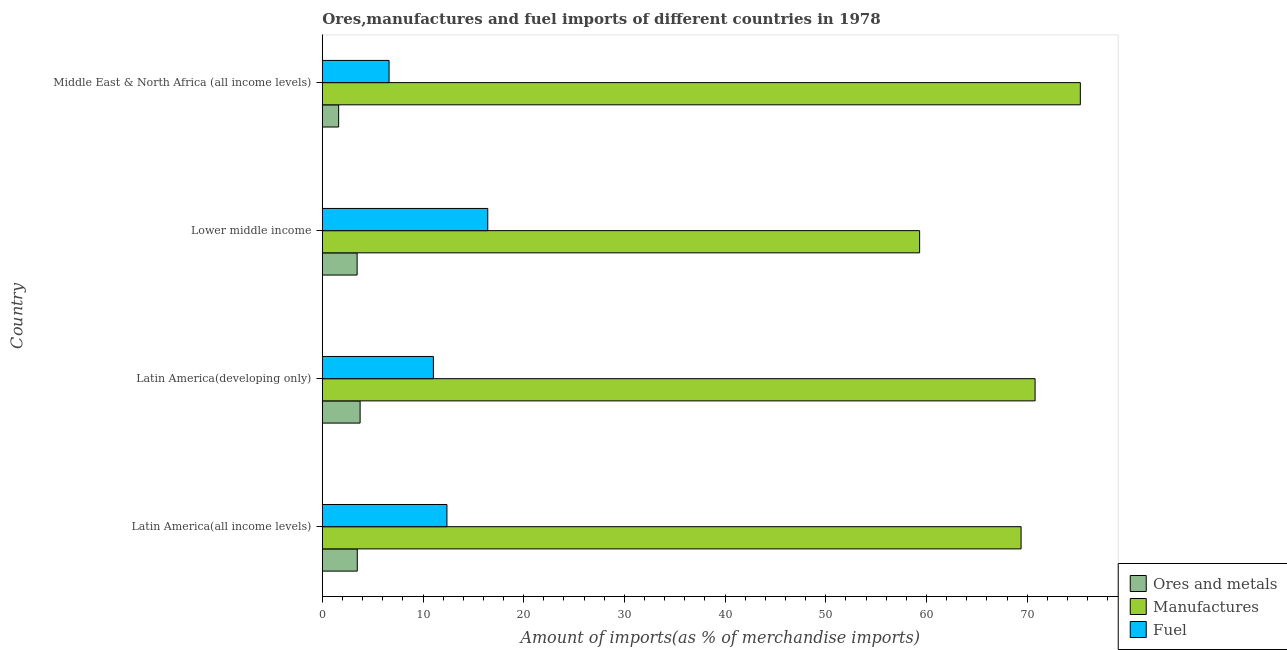How many different coloured bars are there?
Your response must be concise. 3. How many bars are there on the 3rd tick from the top?
Keep it short and to the point. 3. How many bars are there on the 4th tick from the bottom?
Your answer should be very brief. 3. What is the label of the 1st group of bars from the top?
Offer a very short reply. Middle East & North Africa (all income levels). What is the percentage of fuel imports in Lower middle income?
Your answer should be compact. 16.43. Across all countries, what is the maximum percentage of fuel imports?
Your response must be concise. 16.43. Across all countries, what is the minimum percentage of ores and metals imports?
Ensure brevity in your answer.  1.62. In which country was the percentage of manufactures imports maximum?
Provide a short and direct response. Middle East & North Africa (all income levels). In which country was the percentage of ores and metals imports minimum?
Your answer should be compact. Middle East & North Africa (all income levels). What is the total percentage of fuel imports in the graph?
Offer a very short reply. 46.46. What is the difference between the percentage of fuel imports in Latin America(all income levels) and that in Latin America(developing only)?
Your response must be concise. 1.35. What is the difference between the percentage of ores and metals imports in Latin America(developing only) and the percentage of fuel imports in Latin America(all income levels)?
Keep it short and to the point. -8.62. What is the average percentage of ores and metals imports per country?
Keep it short and to the point. 3.08. What is the difference between the percentage of manufactures imports and percentage of ores and metals imports in Middle East & North Africa (all income levels)?
Keep it short and to the point. 73.66. What is the ratio of the percentage of ores and metals imports in Lower middle income to that in Middle East & North Africa (all income levels)?
Offer a very short reply. 2.13. Is the percentage of fuel imports in Latin America(developing only) less than that in Lower middle income?
Provide a short and direct response. Yes. What is the difference between the highest and the second highest percentage of fuel imports?
Your response must be concise. 4.05. Is the sum of the percentage of ores and metals imports in Latin America(developing only) and Middle East & North Africa (all income levels) greater than the maximum percentage of manufactures imports across all countries?
Your response must be concise. No. What does the 3rd bar from the top in Latin America(all income levels) represents?
Keep it short and to the point. Ores and metals. What does the 1st bar from the bottom in Lower middle income represents?
Give a very brief answer. Ores and metals. How many bars are there?
Your answer should be very brief. 12. Are all the bars in the graph horizontal?
Provide a short and direct response. Yes. How many countries are there in the graph?
Keep it short and to the point. 4. Does the graph contain any zero values?
Provide a succinct answer. No. Where does the legend appear in the graph?
Your answer should be compact. Bottom right. How many legend labels are there?
Your answer should be compact. 3. How are the legend labels stacked?
Your response must be concise. Vertical. What is the title of the graph?
Offer a very short reply. Ores,manufactures and fuel imports of different countries in 1978. Does "Unpaid family workers" appear as one of the legend labels in the graph?
Provide a short and direct response. No. What is the label or title of the X-axis?
Make the answer very short. Amount of imports(as % of merchandise imports). What is the Amount of imports(as % of merchandise imports) of Ores and metals in Latin America(all income levels)?
Give a very brief answer. 3.47. What is the Amount of imports(as % of merchandise imports) in Manufactures in Latin America(all income levels)?
Offer a terse response. 69.39. What is the Amount of imports(as % of merchandise imports) in Fuel in Latin America(all income levels)?
Your response must be concise. 12.38. What is the Amount of imports(as % of merchandise imports) in Ores and metals in Latin America(developing only)?
Provide a short and direct response. 3.75. What is the Amount of imports(as % of merchandise imports) of Manufactures in Latin America(developing only)?
Your response must be concise. 70.79. What is the Amount of imports(as % of merchandise imports) in Fuel in Latin America(developing only)?
Give a very brief answer. 11.03. What is the Amount of imports(as % of merchandise imports) in Ores and metals in Lower middle income?
Your answer should be compact. 3.46. What is the Amount of imports(as % of merchandise imports) of Manufactures in Lower middle income?
Keep it short and to the point. 59.32. What is the Amount of imports(as % of merchandise imports) of Fuel in Lower middle income?
Your answer should be compact. 16.43. What is the Amount of imports(as % of merchandise imports) of Ores and metals in Middle East & North Africa (all income levels)?
Give a very brief answer. 1.62. What is the Amount of imports(as % of merchandise imports) in Manufactures in Middle East & North Africa (all income levels)?
Offer a very short reply. 75.28. What is the Amount of imports(as % of merchandise imports) of Fuel in Middle East & North Africa (all income levels)?
Keep it short and to the point. 6.63. Across all countries, what is the maximum Amount of imports(as % of merchandise imports) in Ores and metals?
Provide a short and direct response. 3.75. Across all countries, what is the maximum Amount of imports(as % of merchandise imports) in Manufactures?
Your response must be concise. 75.28. Across all countries, what is the maximum Amount of imports(as % of merchandise imports) in Fuel?
Ensure brevity in your answer.  16.43. Across all countries, what is the minimum Amount of imports(as % of merchandise imports) of Ores and metals?
Make the answer very short. 1.62. Across all countries, what is the minimum Amount of imports(as % of merchandise imports) in Manufactures?
Offer a very short reply. 59.32. Across all countries, what is the minimum Amount of imports(as % of merchandise imports) in Fuel?
Keep it short and to the point. 6.63. What is the total Amount of imports(as % of merchandise imports) in Ores and metals in the graph?
Give a very brief answer. 12.3. What is the total Amount of imports(as % of merchandise imports) in Manufactures in the graph?
Offer a very short reply. 274.78. What is the total Amount of imports(as % of merchandise imports) in Fuel in the graph?
Your answer should be compact. 46.46. What is the difference between the Amount of imports(as % of merchandise imports) of Ores and metals in Latin America(all income levels) and that in Latin America(developing only)?
Provide a succinct answer. -0.28. What is the difference between the Amount of imports(as % of merchandise imports) of Manufactures in Latin America(all income levels) and that in Latin America(developing only)?
Make the answer very short. -1.39. What is the difference between the Amount of imports(as % of merchandise imports) in Fuel in Latin America(all income levels) and that in Latin America(developing only)?
Give a very brief answer. 1.35. What is the difference between the Amount of imports(as % of merchandise imports) in Ores and metals in Latin America(all income levels) and that in Lower middle income?
Provide a short and direct response. 0.02. What is the difference between the Amount of imports(as % of merchandise imports) of Manufactures in Latin America(all income levels) and that in Lower middle income?
Offer a terse response. 10.08. What is the difference between the Amount of imports(as % of merchandise imports) in Fuel in Latin America(all income levels) and that in Lower middle income?
Provide a succinct answer. -4.05. What is the difference between the Amount of imports(as % of merchandise imports) in Ores and metals in Latin America(all income levels) and that in Middle East & North Africa (all income levels)?
Offer a terse response. 1.85. What is the difference between the Amount of imports(as % of merchandise imports) of Manufactures in Latin America(all income levels) and that in Middle East & North Africa (all income levels)?
Ensure brevity in your answer.  -5.88. What is the difference between the Amount of imports(as % of merchandise imports) of Fuel in Latin America(all income levels) and that in Middle East & North Africa (all income levels)?
Your answer should be very brief. 5.75. What is the difference between the Amount of imports(as % of merchandise imports) in Ores and metals in Latin America(developing only) and that in Lower middle income?
Your answer should be very brief. 0.3. What is the difference between the Amount of imports(as % of merchandise imports) of Manufactures in Latin America(developing only) and that in Lower middle income?
Provide a short and direct response. 11.47. What is the difference between the Amount of imports(as % of merchandise imports) of Fuel in Latin America(developing only) and that in Lower middle income?
Make the answer very short. -5.4. What is the difference between the Amount of imports(as % of merchandise imports) in Ores and metals in Latin America(developing only) and that in Middle East & North Africa (all income levels)?
Make the answer very short. 2.13. What is the difference between the Amount of imports(as % of merchandise imports) of Manufactures in Latin America(developing only) and that in Middle East & North Africa (all income levels)?
Offer a terse response. -4.49. What is the difference between the Amount of imports(as % of merchandise imports) of Fuel in Latin America(developing only) and that in Middle East & North Africa (all income levels)?
Provide a short and direct response. 4.4. What is the difference between the Amount of imports(as % of merchandise imports) in Ores and metals in Lower middle income and that in Middle East & North Africa (all income levels)?
Provide a succinct answer. 1.84. What is the difference between the Amount of imports(as % of merchandise imports) in Manufactures in Lower middle income and that in Middle East & North Africa (all income levels)?
Offer a terse response. -15.96. What is the difference between the Amount of imports(as % of merchandise imports) in Fuel in Lower middle income and that in Middle East & North Africa (all income levels)?
Offer a terse response. 9.8. What is the difference between the Amount of imports(as % of merchandise imports) of Ores and metals in Latin America(all income levels) and the Amount of imports(as % of merchandise imports) of Manufactures in Latin America(developing only)?
Offer a terse response. -67.32. What is the difference between the Amount of imports(as % of merchandise imports) in Ores and metals in Latin America(all income levels) and the Amount of imports(as % of merchandise imports) in Fuel in Latin America(developing only)?
Your response must be concise. -7.56. What is the difference between the Amount of imports(as % of merchandise imports) in Manufactures in Latin America(all income levels) and the Amount of imports(as % of merchandise imports) in Fuel in Latin America(developing only)?
Give a very brief answer. 58.37. What is the difference between the Amount of imports(as % of merchandise imports) of Ores and metals in Latin America(all income levels) and the Amount of imports(as % of merchandise imports) of Manufactures in Lower middle income?
Your answer should be very brief. -55.85. What is the difference between the Amount of imports(as % of merchandise imports) in Ores and metals in Latin America(all income levels) and the Amount of imports(as % of merchandise imports) in Fuel in Lower middle income?
Ensure brevity in your answer.  -12.96. What is the difference between the Amount of imports(as % of merchandise imports) of Manufactures in Latin America(all income levels) and the Amount of imports(as % of merchandise imports) of Fuel in Lower middle income?
Your answer should be very brief. 52.97. What is the difference between the Amount of imports(as % of merchandise imports) of Ores and metals in Latin America(all income levels) and the Amount of imports(as % of merchandise imports) of Manufactures in Middle East & North Africa (all income levels)?
Provide a short and direct response. -71.81. What is the difference between the Amount of imports(as % of merchandise imports) in Ores and metals in Latin America(all income levels) and the Amount of imports(as % of merchandise imports) in Fuel in Middle East & North Africa (all income levels)?
Offer a terse response. -3.16. What is the difference between the Amount of imports(as % of merchandise imports) in Manufactures in Latin America(all income levels) and the Amount of imports(as % of merchandise imports) in Fuel in Middle East & North Africa (all income levels)?
Your answer should be compact. 62.77. What is the difference between the Amount of imports(as % of merchandise imports) of Ores and metals in Latin America(developing only) and the Amount of imports(as % of merchandise imports) of Manufactures in Lower middle income?
Keep it short and to the point. -55.57. What is the difference between the Amount of imports(as % of merchandise imports) of Ores and metals in Latin America(developing only) and the Amount of imports(as % of merchandise imports) of Fuel in Lower middle income?
Make the answer very short. -12.68. What is the difference between the Amount of imports(as % of merchandise imports) in Manufactures in Latin America(developing only) and the Amount of imports(as % of merchandise imports) in Fuel in Lower middle income?
Offer a terse response. 54.36. What is the difference between the Amount of imports(as % of merchandise imports) of Ores and metals in Latin America(developing only) and the Amount of imports(as % of merchandise imports) of Manufactures in Middle East & North Africa (all income levels)?
Provide a succinct answer. -71.53. What is the difference between the Amount of imports(as % of merchandise imports) in Ores and metals in Latin America(developing only) and the Amount of imports(as % of merchandise imports) in Fuel in Middle East & North Africa (all income levels)?
Ensure brevity in your answer.  -2.88. What is the difference between the Amount of imports(as % of merchandise imports) of Manufactures in Latin America(developing only) and the Amount of imports(as % of merchandise imports) of Fuel in Middle East & North Africa (all income levels)?
Keep it short and to the point. 64.16. What is the difference between the Amount of imports(as % of merchandise imports) in Ores and metals in Lower middle income and the Amount of imports(as % of merchandise imports) in Manufactures in Middle East & North Africa (all income levels)?
Your response must be concise. -71.82. What is the difference between the Amount of imports(as % of merchandise imports) of Ores and metals in Lower middle income and the Amount of imports(as % of merchandise imports) of Fuel in Middle East & North Africa (all income levels)?
Offer a terse response. -3.17. What is the difference between the Amount of imports(as % of merchandise imports) of Manufactures in Lower middle income and the Amount of imports(as % of merchandise imports) of Fuel in Middle East & North Africa (all income levels)?
Offer a very short reply. 52.69. What is the average Amount of imports(as % of merchandise imports) of Ores and metals per country?
Give a very brief answer. 3.07. What is the average Amount of imports(as % of merchandise imports) of Manufactures per country?
Ensure brevity in your answer.  68.69. What is the average Amount of imports(as % of merchandise imports) in Fuel per country?
Provide a short and direct response. 11.62. What is the difference between the Amount of imports(as % of merchandise imports) in Ores and metals and Amount of imports(as % of merchandise imports) in Manufactures in Latin America(all income levels)?
Make the answer very short. -65.92. What is the difference between the Amount of imports(as % of merchandise imports) of Ores and metals and Amount of imports(as % of merchandise imports) of Fuel in Latin America(all income levels)?
Keep it short and to the point. -8.9. What is the difference between the Amount of imports(as % of merchandise imports) of Manufactures and Amount of imports(as % of merchandise imports) of Fuel in Latin America(all income levels)?
Your answer should be very brief. 57.02. What is the difference between the Amount of imports(as % of merchandise imports) of Ores and metals and Amount of imports(as % of merchandise imports) of Manufactures in Latin America(developing only)?
Your answer should be very brief. -67.03. What is the difference between the Amount of imports(as % of merchandise imports) of Ores and metals and Amount of imports(as % of merchandise imports) of Fuel in Latin America(developing only)?
Offer a terse response. -7.28. What is the difference between the Amount of imports(as % of merchandise imports) of Manufactures and Amount of imports(as % of merchandise imports) of Fuel in Latin America(developing only)?
Your answer should be very brief. 59.76. What is the difference between the Amount of imports(as % of merchandise imports) in Ores and metals and Amount of imports(as % of merchandise imports) in Manufactures in Lower middle income?
Make the answer very short. -55.86. What is the difference between the Amount of imports(as % of merchandise imports) of Ores and metals and Amount of imports(as % of merchandise imports) of Fuel in Lower middle income?
Your answer should be compact. -12.97. What is the difference between the Amount of imports(as % of merchandise imports) in Manufactures and Amount of imports(as % of merchandise imports) in Fuel in Lower middle income?
Offer a terse response. 42.89. What is the difference between the Amount of imports(as % of merchandise imports) of Ores and metals and Amount of imports(as % of merchandise imports) of Manufactures in Middle East & North Africa (all income levels)?
Ensure brevity in your answer.  -73.66. What is the difference between the Amount of imports(as % of merchandise imports) of Ores and metals and Amount of imports(as % of merchandise imports) of Fuel in Middle East & North Africa (all income levels)?
Provide a short and direct response. -5.01. What is the difference between the Amount of imports(as % of merchandise imports) in Manufactures and Amount of imports(as % of merchandise imports) in Fuel in Middle East & North Africa (all income levels)?
Provide a short and direct response. 68.65. What is the ratio of the Amount of imports(as % of merchandise imports) of Ores and metals in Latin America(all income levels) to that in Latin America(developing only)?
Provide a short and direct response. 0.93. What is the ratio of the Amount of imports(as % of merchandise imports) of Manufactures in Latin America(all income levels) to that in Latin America(developing only)?
Provide a succinct answer. 0.98. What is the ratio of the Amount of imports(as % of merchandise imports) of Fuel in Latin America(all income levels) to that in Latin America(developing only)?
Keep it short and to the point. 1.12. What is the ratio of the Amount of imports(as % of merchandise imports) in Manufactures in Latin America(all income levels) to that in Lower middle income?
Your answer should be compact. 1.17. What is the ratio of the Amount of imports(as % of merchandise imports) in Fuel in Latin America(all income levels) to that in Lower middle income?
Offer a very short reply. 0.75. What is the ratio of the Amount of imports(as % of merchandise imports) of Ores and metals in Latin America(all income levels) to that in Middle East & North Africa (all income levels)?
Offer a terse response. 2.14. What is the ratio of the Amount of imports(as % of merchandise imports) in Manufactures in Latin America(all income levels) to that in Middle East & North Africa (all income levels)?
Make the answer very short. 0.92. What is the ratio of the Amount of imports(as % of merchandise imports) in Fuel in Latin America(all income levels) to that in Middle East & North Africa (all income levels)?
Give a very brief answer. 1.87. What is the ratio of the Amount of imports(as % of merchandise imports) of Ores and metals in Latin America(developing only) to that in Lower middle income?
Provide a succinct answer. 1.09. What is the ratio of the Amount of imports(as % of merchandise imports) in Manufactures in Latin America(developing only) to that in Lower middle income?
Keep it short and to the point. 1.19. What is the ratio of the Amount of imports(as % of merchandise imports) of Fuel in Latin America(developing only) to that in Lower middle income?
Provide a short and direct response. 0.67. What is the ratio of the Amount of imports(as % of merchandise imports) of Ores and metals in Latin America(developing only) to that in Middle East & North Africa (all income levels)?
Offer a very short reply. 2.32. What is the ratio of the Amount of imports(as % of merchandise imports) of Manufactures in Latin America(developing only) to that in Middle East & North Africa (all income levels)?
Offer a very short reply. 0.94. What is the ratio of the Amount of imports(as % of merchandise imports) of Fuel in Latin America(developing only) to that in Middle East & North Africa (all income levels)?
Give a very brief answer. 1.66. What is the ratio of the Amount of imports(as % of merchandise imports) of Ores and metals in Lower middle income to that in Middle East & North Africa (all income levels)?
Your answer should be compact. 2.13. What is the ratio of the Amount of imports(as % of merchandise imports) in Manufactures in Lower middle income to that in Middle East & North Africa (all income levels)?
Your answer should be compact. 0.79. What is the ratio of the Amount of imports(as % of merchandise imports) of Fuel in Lower middle income to that in Middle East & North Africa (all income levels)?
Your answer should be very brief. 2.48. What is the difference between the highest and the second highest Amount of imports(as % of merchandise imports) of Ores and metals?
Your answer should be very brief. 0.28. What is the difference between the highest and the second highest Amount of imports(as % of merchandise imports) in Manufactures?
Offer a terse response. 4.49. What is the difference between the highest and the second highest Amount of imports(as % of merchandise imports) of Fuel?
Your answer should be very brief. 4.05. What is the difference between the highest and the lowest Amount of imports(as % of merchandise imports) of Ores and metals?
Your answer should be compact. 2.13. What is the difference between the highest and the lowest Amount of imports(as % of merchandise imports) of Manufactures?
Give a very brief answer. 15.96. What is the difference between the highest and the lowest Amount of imports(as % of merchandise imports) in Fuel?
Your response must be concise. 9.8. 